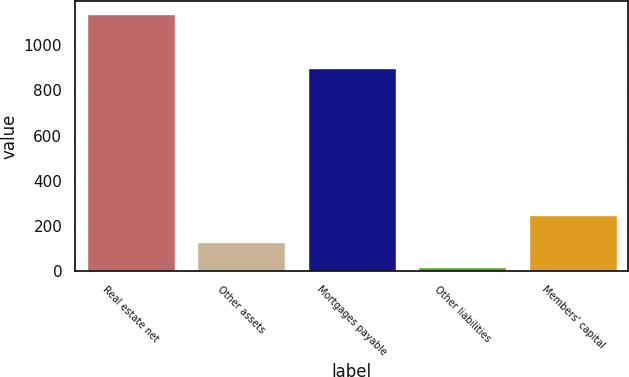Convert chart to OTSL. <chart><loc_0><loc_0><loc_500><loc_500><bar_chart><fcel>Real estate net<fcel>Other assets<fcel>Mortgages payable<fcel>Other liabilities<fcel>Members' capital<nl><fcel>1137.4<fcel>128.5<fcel>899.4<fcel>16.4<fcel>245.9<nl></chart> 